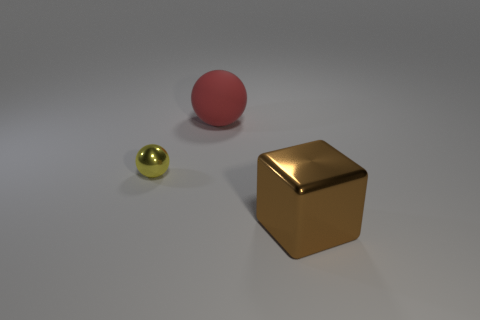There is a large brown thing; are there any small yellow things in front of it?
Ensure brevity in your answer.  No. What is the shape of the red matte thing?
Provide a short and direct response. Sphere. What is the shape of the large thing to the left of the shiny thing right of the thing that is behind the small ball?
Offer a very short reply. Sphere. How many other objects are there of the same shape as the small yellow metallic object?
Give a very brief answer. 1. There is a big object behind the brown object that is in front of the large sphere; what is its material?
Your response must be concise. Rubber. Is there any other thing that is the same size as the red matte thing?
Make the answer very short. Yes. Does the tiny yellow object have the same material as the thing that is to the right of the large red object?
Provide a short and direct response. Yes. What is the object that is both in front of the big red thing and right of the tiny shiny sphere made of?
Give a very brief answer. Metal. There is a object that is behind the sphere left of the large red rubber sphere; what color is it?
Your answer should be very brief. Red. What is the material of the object that is in front of the tiny metal sphere?
Offer a very short reply. Metal. 